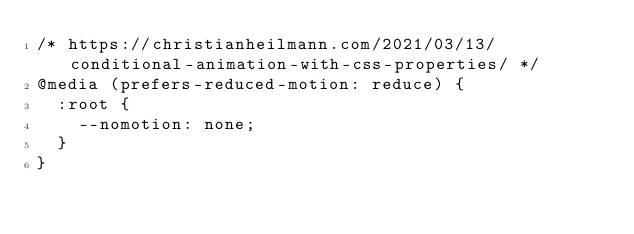<code> <loc_0><loc_0><loc_500><loc_500><_CSS_>/* https://christianheilmann.com/2021/03/13/conditional-animation-with-css-properties/ */
@media (prefers-reduced-motion: reduce) {
  :root {
    --nomotion: none;
  }
}
</code> 